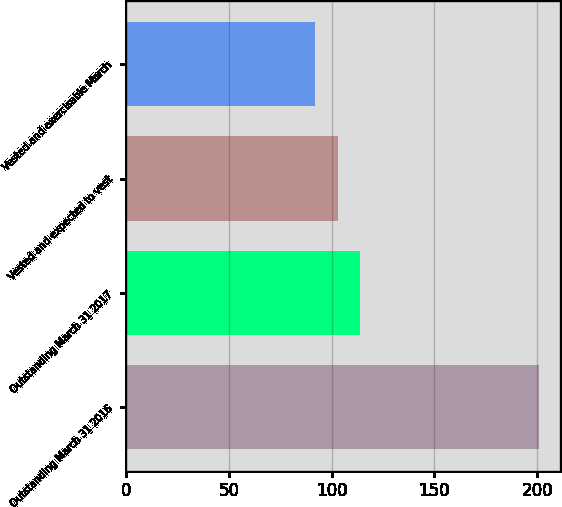Convert chart to OTSL. <chart><loc_0><loc_0><loc_500><loc_500><bar_chart><fcel>Outstanding March 31 2016<fcel>Outstanding March 31 2017<fcel>Vested and expected to vest<fcel>Vested and exercisable March<nl><fcel>201<fcel>113.8<fcel>102.9<fcel>92<nl></chart> 